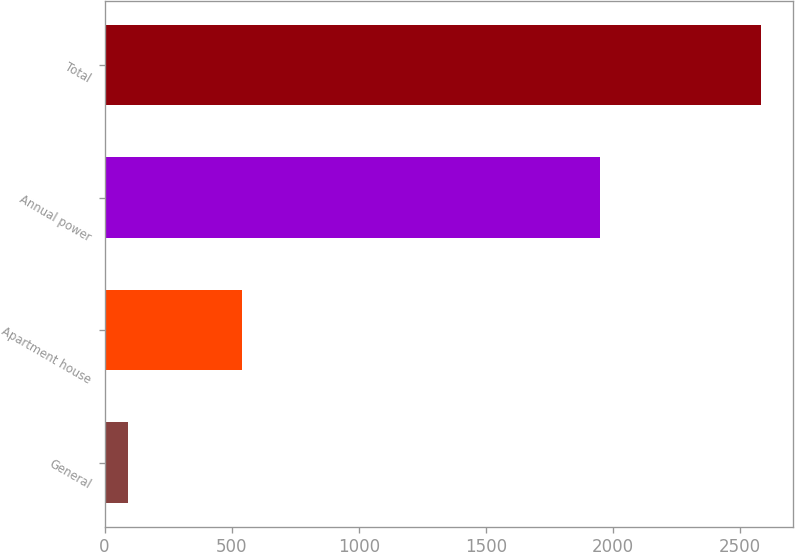Convert chart. <chart><loc_0><loc_0><loc_500><loc_500><bar_chart><fcel>General<fcel>Apartment house<fcel>Annual power<fcel>Total<nl><fcel>94<fcel>539<fcel>1948<fcel>2581<nl></chart> 